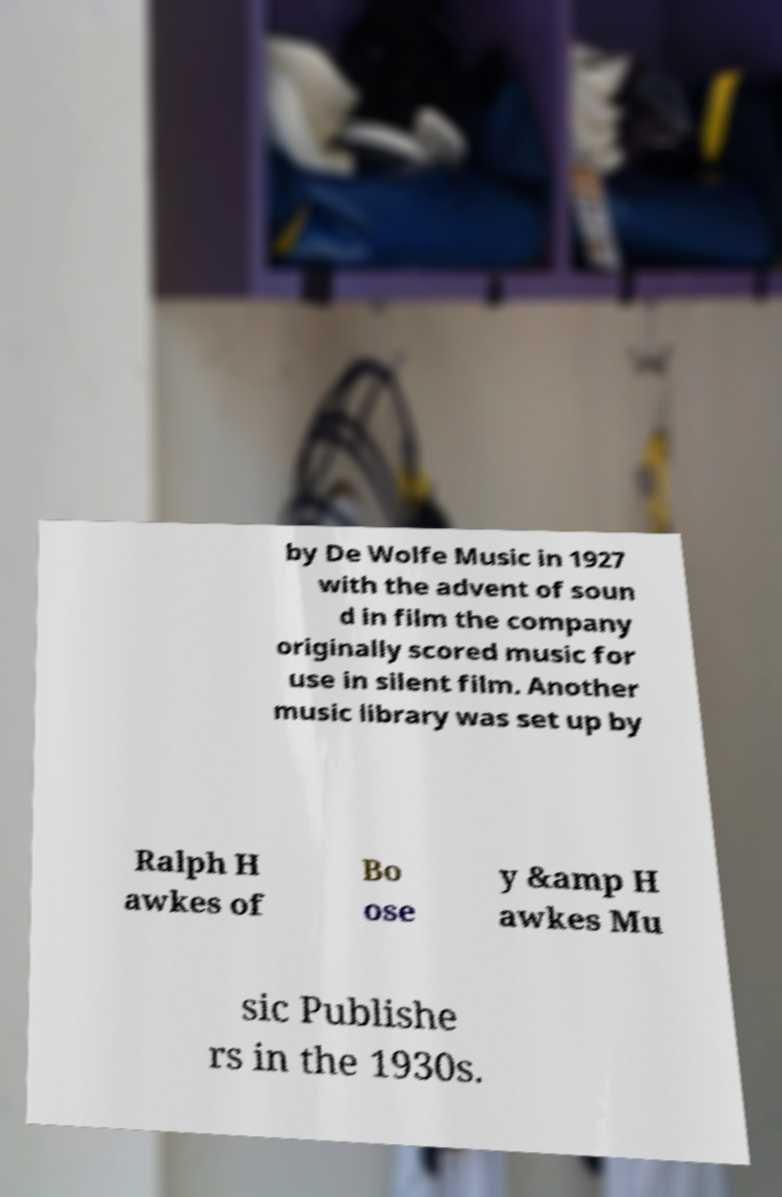Could you extract and type out the text from this image? by De Wolfe Music in 1927 with the advent of soun d in film the company originally scored music for use in silent film. Another music library was set up by Ralph H awkes of Bo ose y &amp H awkes Mu sic Publishe rs in the 1930s. 